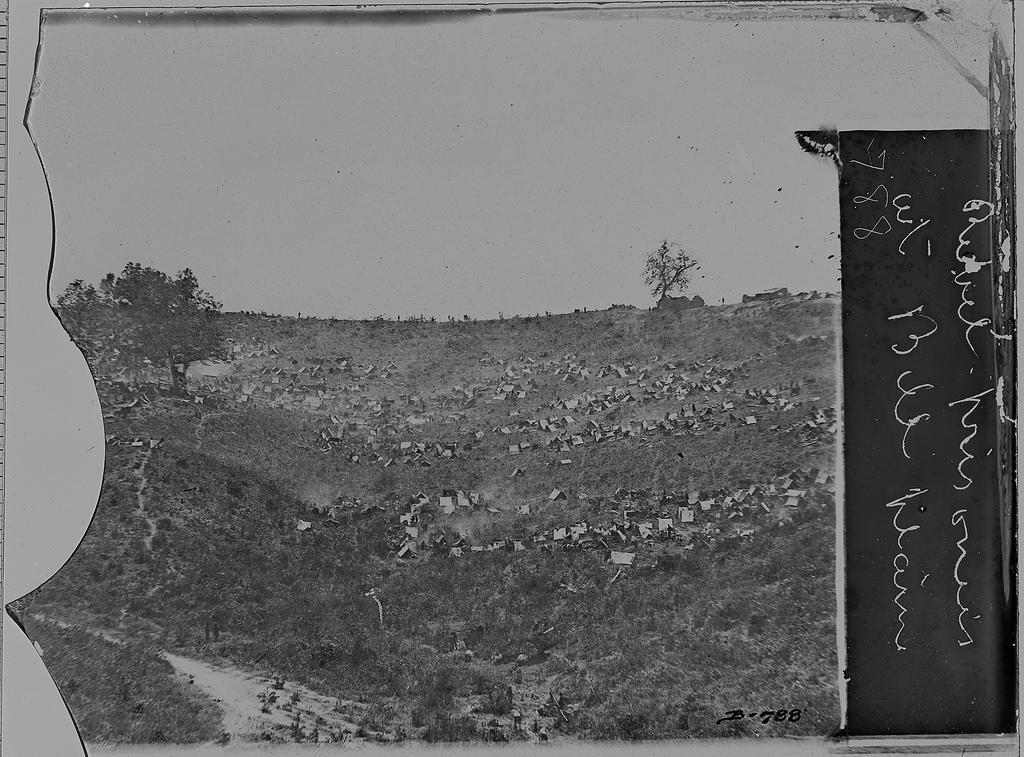Can you describe this image briefly? In this picture we can see black and white photography of the ground with some trees and grass. On the right corner we can see something is written on the photograph. 